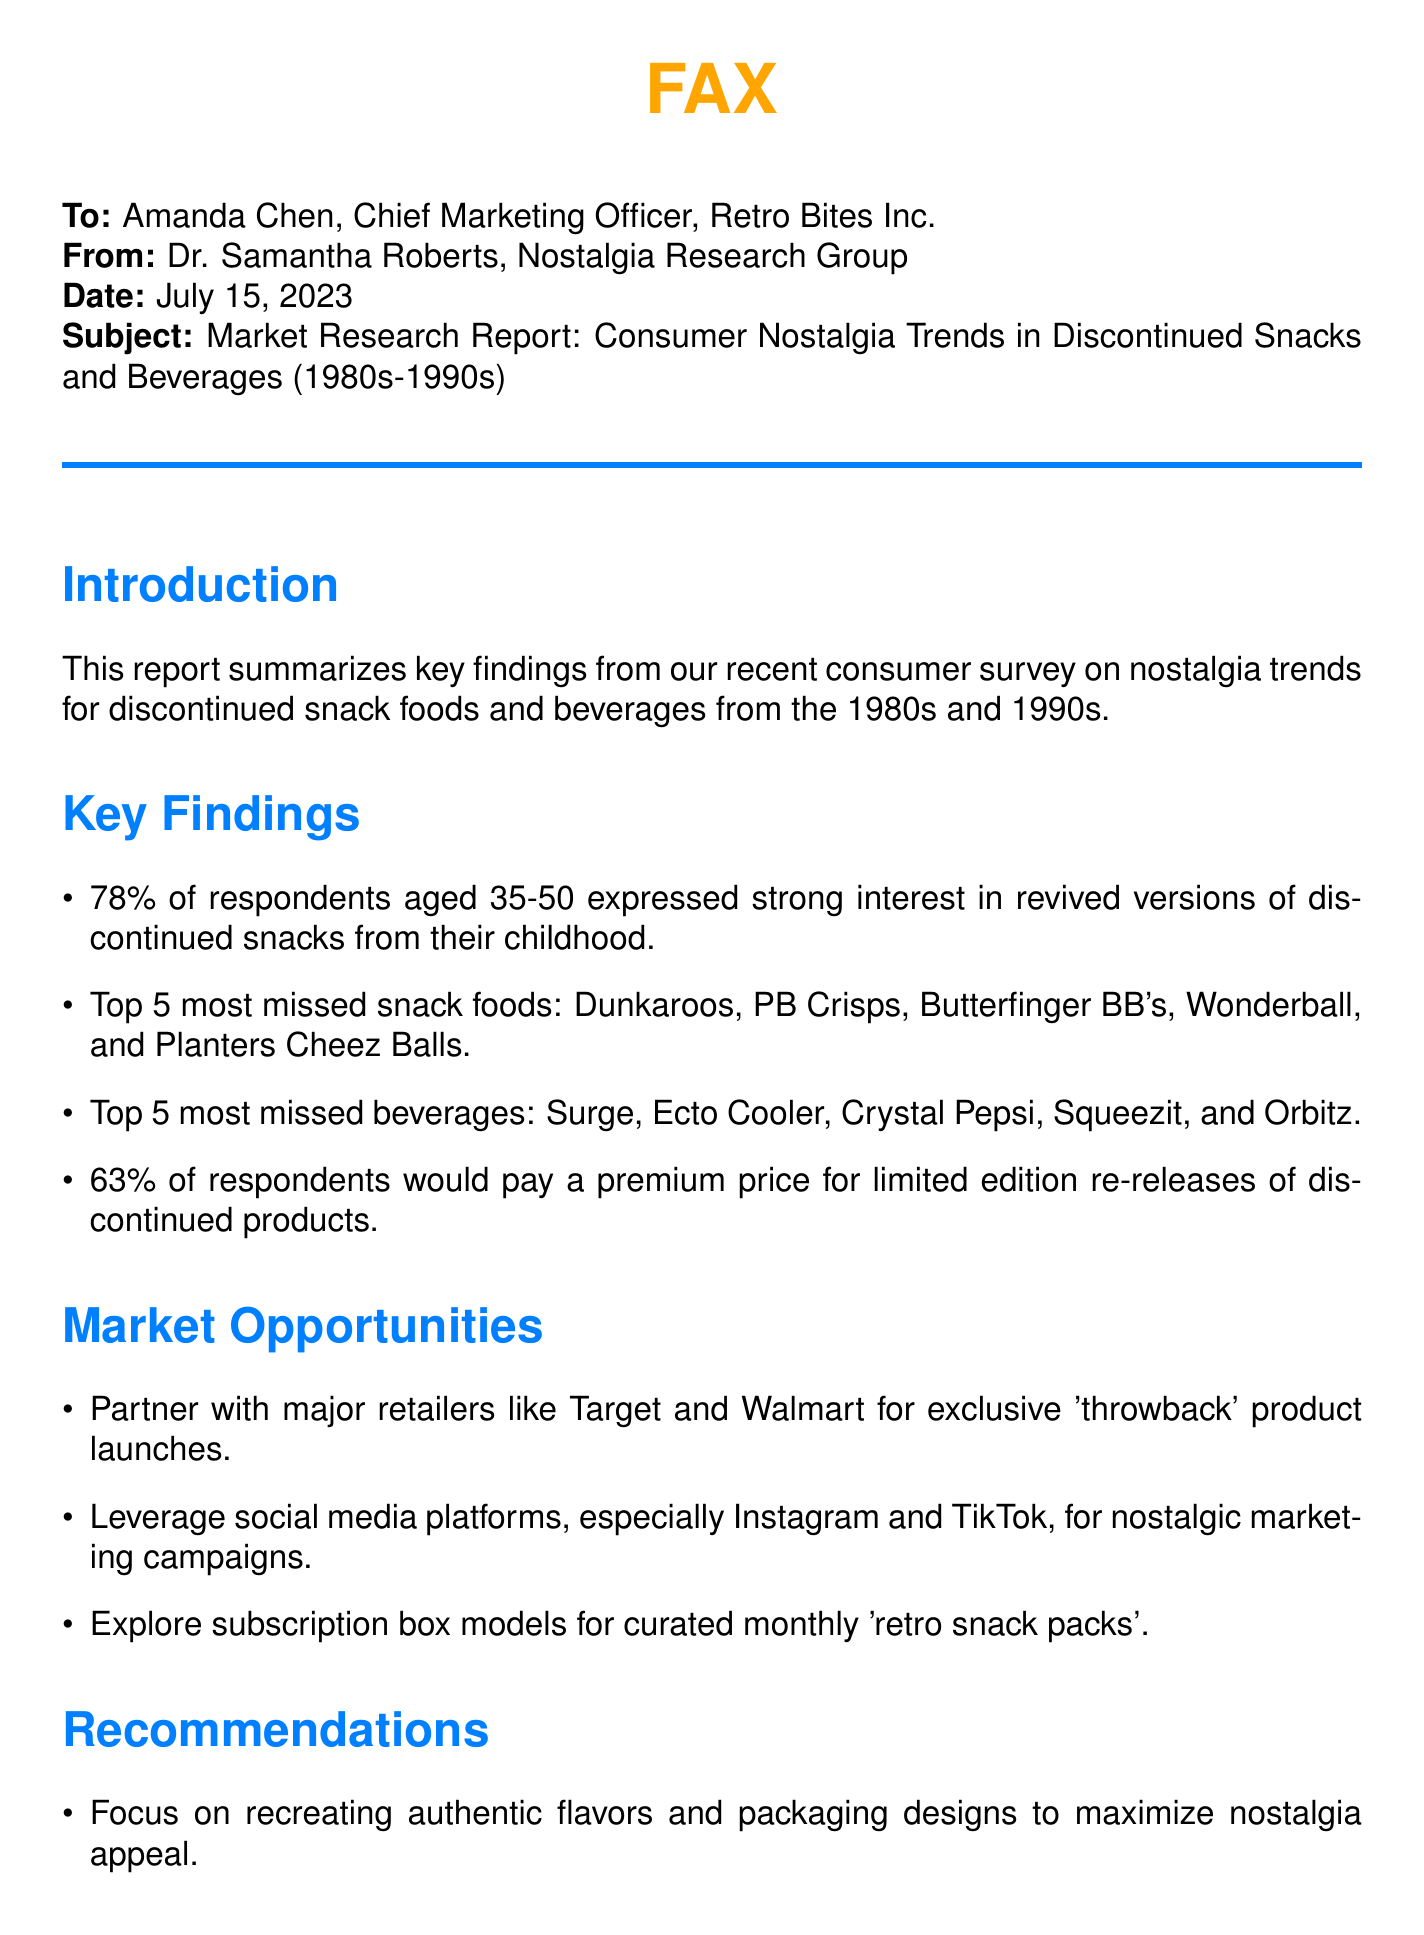what is the date of the report? The date of the report is stated at the beginning of the document as July 15, 2023.
Answer: July 15, 2023 who is the sender of the report? The sender of the report is mentioned as Dr. Samantha Roberts from the Nostalgia Research Group.
Answer: Dr. Samantha Roberts what percentage of respondents would pay a premium price? The document states that 63% of respondents would pay a premium price for re-releases.
Answer: 63% which snack food is the most missed? The report lists Dunkaroos as the top most missed snack food among respondents.
Answer: Dunkaroos what marketing strategy is suggested for partnerships? The document suggests partnering with major retailers for exclusive product launches as a marketing strategy.
Answer: Exclusive product launches how many respondents expressed interest in revived snacks? The document indicates that 78% of respondents aged 35-50 expressed interest in revived snacks.
Answer: 78% what is a proposed subscription model idea? The document proposes a subscription box model for curated monthly 'retro snack packs'.
Answer: Retro snack packs which beverage is mentioned as a top nostalgia item? Ecto Cooler is listed as one of the top missed beverages in the report.
Answer: Ecto Cooler what color is used for section titles? The document specifies that section titles are in retro blue color.
Answer: Retro blue 